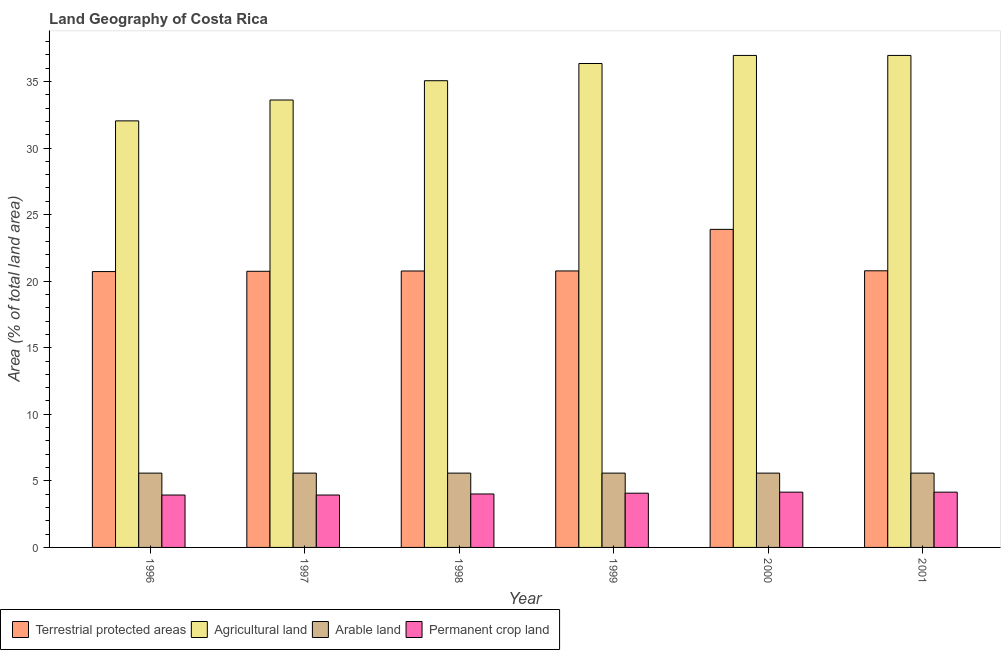How many different coloured bars are there?
Keep it short and to the point. 4. Are the number of bars on each tick of the X-axis equal?
Keep it short and to the point. Yes. What is the percentage of land under terrestrial protection in 2000?
Provide a succinct answer. 23.89. Across all years, what is the maximum percentage of area under agricultural land?
Offer a terse response. 36.96. Across all years, what is the minimum percentage of area under agricultural land?
Your answer should be very brief. 32.04. What is the total percentage of area under arable land in the graph?
Offer a terse response. 33.49. What is the difference between the percentage of area under arable land in 1996 and that in 1999?
Your answer should be compact. 0. What is the difference between the percentage of area under permanent crop land in 1997 and the percentage of area under arable land in 1998?
Provide a short and direct response. -0.08. What is the average percentage of area under permanent crop land per year?
Your answer should be compact. 4.04. In the year 2001, what is the difference between the percentage of area under permanent crop land and percentage of area under agricultural land?
Make the answer very short. 0. In how many years, is the percentage of land under terrestrial protection greater than 25 %?
Your answer should be compact. 0. What is the ratio of the percentage of area under arable land in 1997 to that in 2000?
Your response must be concise. 1. Is the percentage of area under permanent crop land in 1996 less than that in 2001?
Provide a succinct answer. Yes. Is the difference between the percentage of area under agricultural land in 1997 and 2001 greater than the difference between the percentage of area under arable land in 1997 and 2001?
Provide a succinct answer. No. What is the difference between the highest and the second highest percentage of area under arable land?
Your response must be concise. 0. What is the difference between the highest and the lowest percentage of land under terrestrial protection?
Ensure brevity in your answer.  3.17. In how many years, is the percentage of land under terrestrial protection greater than the average percentage of land under terrestrial protection taken over all years?
Give a very brief answer. 1. What does the 2nd bar from the left in 1998 represents?
Make the answer very short. Agricultural land. What does the 4th bar from the right in 1996 represents?
Your answer should be compact. Terrestrial protected areas. Is it the case that in every year, the sum of the percentage of land under terrestrial protection and percentage of area under agricultural land is greater than the percentage of area under arable land?
Provide a succinct answer. Yes. Where does the legend appear in the graph?
Your response must be concise. Bottom left. How many legend labels are there?
Your answer should be compact. 4. What is the title of the graph?
Provide a succinct answer. Land Geography of Costa Rica. What is the label or title of the X-axis?
Give a very brief answer. Year. What is the label or title of the Y-axis?
Provide a short and direct response. Area (% of total land area). What is the Area (% of total land area) of Terrestrial protected areas in 1996?
Provide a short and direct response. 20.72. What is the Area (% of total land area) of Agricultural land in 1996?
Offer a very short reply. 32.04. What is the Area (% of total land area) of Arable land in 1996?
Ensure brevity in your answer.  5.58. What is the Area (% of total land area) of Permanent crop land in 1996?
Make the answer very short. 3.94. What is the Area (% of total land area) in Terrestrial protected areas in 1997?
Your response must be concise. 20.74. What is the Area (% of total land area) in Agricultural land in 1997?
Keep it short and to the point. 33.61. What is the Area (% of total land area) of Arable land in 1997?
Provide a succinct answer. 5.58. What is the Area (% of total land area) in Permanent crop land in 1997?
Your answer should be compact. 3.94. What is the Area (% of total land area) of Terrestrial protected areas in 1998?
Offer a terse response. 20.76. What is the Area (% of total land area) of Agricultural land in 1998?
Your answer should be compact. 35.06. What is the Area (% of total land area) of Arable land in 1998?
Keep it short and to the point. 5.58. What is the Area (% of total land area) in Permanent crop land in 1998?
Your answer should be very brief. 4.01. What is the Area (% of total land area) in Terrestrial protected areas in 1999?
Keep it short and to the point. 20.77. What is the Area (% of total land area) in Agricultural land in 1999?
Offer a very short reply. 36.35. What is the Area (% of total land area) in Arable land in 1999?
Ensure brevity in your answer.  5.58. What is the Area (% of total land area) of Permanent crop land in 1999?
Ensure brevity in your answer.  4.07. What is the Area (% of total land area) of Terrestrial protected areas in 2000?
Keep it short and to the point. 23.89. What is the Area (% of total land area) in Agricultural land in 2000?
Offer a terse response. 36.96. What is the Area (% of total land area) in Arable land in 2000?
Your response must be concise. 5.58. What is the Area (% of total land area) in Permanent crop land in 2000?
Your answer should be compact. 4.15. What is the Area (% of total land area) of Terrestrial protected areas in 2001?
Offer a very short reply. 20.78. What is the Area (% of total land area) in Agricultural land in 2001?
Make the answer very short. 36.96. What is the Area (% of total land area) of Arable land in 2001?
Offer a very short reply. 5.58. What is the Area (% of total land area) in Permanent crop land in 2001?
Offer a terse response. 4.15. Across all years, what is the maximum Area (% of total land area) of Terrestrial protected areas?
Ensure brevity in your answer.  23.89. Across all years, what is the maximum Area (% of total land area) of Agricultural land?
Offer a very short reply. 36.96. Across all years, what is the maximum Area (% of total land area) of Arable land?
Your response must be concise. 5.58. Across all years, what is the maximum Area (% of total land area) of Permanent crop land?
Make the answer very short. 4.15. Across all years, what is the minimum Area (% of total land area) in Terrestrial protected areas?
Your answer should be very brief. 20.72. Across all years, what is the minimum Area (% of total land area) of Agricultural land?
Keep it short and to the point. 32.04. Across all years, what is the minimum Area (% of total land area) in Arable land?
Your answer should be very brief. 5.58. Across all years, what is the minimum Area (% of total land area) of Permanent crop land?
Your response must be concise. 3.94. What is the total Area (% of total land area) of Terrestrial protected areas in the graph?
Offer a very short reply. 127.67. What is the total Area (% of total land area) of Agricultural land in the graph?
Give a very brief answer. 210.97. What is the total Area (% of total land area) of Arable land in the graph?
Your answer should be very brief. 33.49. What is the total Area (% of total land area) in Permanent crop land in the graph?
Offer a very short reply. 24.27. What is the difference between the Area (% of total land area) of Terrestrial protected areas in 1996 and that in 1997?
Offer a terse response. -0.02. What is the difference between the Area (% of total land area) in Agricultural land in 1996 and that in 1997?
Your response must be concise. -1.57. What is the difference between the Area (% of total land area) of Arable land in 1996 and that in 1997?
Ensure brevity in your answer.  0. What is the difference between the Area (% of total land area) of Permanent crop land in 1996 and that in 1997?
Your answer should be compact. 0. What is the difference between the Area (% of total land area) in Terrestrial protected areas in 1996 and that in 1998?
Keep it short and to the point. -0.04. What is the difference between the Area (% of total land area) of Agricultural land in 1996 and that in 1998?
Your answer should be very brief. -3.02. What is the difference between the Area (% of total land area) in Permanent crop land in 1996 and that in 1998?
Keep it short and to the point. -0.08. What is the difference between the Area (% of total land area) of Terrestrial protected areas in 1996 and that in 1999?
Offer a terse response. -0.05. What is the difference between the Area (% of total land area) of Agricultural land in 1996 and that in 1999?
Your response must be concise. -4.31. What is the difference between the Area (% of total land area) of Permanent crop land in 1996 and that in 1999?
Your answer should be very brief. -0.14. What is the difference between the Area (% of total land area) of Terrestrial protected areas in 1996 and that in 2000?
Keep it short and to the point. -3.17. What is the difference between the Area (% of total land area) of Agricultural land in 1996 and that in 2000?
Make the answer very short. -4.92. What is the difference between the Area (% of total land area) of Arable land in 1996 and that in 2000?
Provide a succinct answer. 0. What is the difference between the Area (% of total land area) in Permanent crop land in 1996 and that in 2000?
Offer a terse response. -0.22. What is the difference between the Area (% of total land area) in Terrestrial protected areas in 1996 and that in 2001?
Your response must be concise. -0.06. What is the difference between the Area (% of total land area) in Agricultural land in 1996 and that in 2001?
Give a very brief answer. -4.92. What is the difference between the Area (% of total land area) of Arable land in 1996 and that in 2001?
Offer a terse response. 0. What is the difference between the Area (% of total land area) in Permanent crop land in 1996 and that in 2001?
Make the answer very short. -0.22. What is the difference between the Area (% of total land area) in Terrestrial protected areas in 1997 and that in 1998?
Give a very brief answer. -0.02. What is the difference between the Area (% of total land area) of Agricultural land in 1997 and that in 1998?
Offer a very short reply. -1.45. What is the difference between the Area (% of total land area) of Permanent crop land in 1997 and that in 1998?
Offer a very short reply. -0.08. What is the difference between the Area (% of total land area) of Terrestrial protected areas in 1997 and that in 1999?
Offer a very short reply. -0.03. What is the difference between the Area (% of total land area) in Agricultural land in 1997 and that in 1999?
Provide a short and direct response. -2.74. What is the difference between the Area (% of total land area) of Permanent crop land in 1997 and that in 1999?
Provide a succinct answer. -0.14. What is the difference between the Area (% of total land area) in Terrestrial protected areas in 1997 and that in 2000?
Offer a very short reply. -3.15. What is the difference between the Area (% of total land area) of Agricultural land in 1997 and that in 2000?
Your response must be concise. -3.35. What is the difference between the Area (% of total land area) in Permanent crop land in 1997 and that in 2000?
Keep it short and to the point. -0.22. What is the difference between the Area (% of total land area) in Terrestrial protected areas in 1997 and that in 2001?
Keep it short and to the point. -0.04. What is the difference between the Area (% of total land area) of Agricultural land in 1997 and that in 2001?
Offer a terse response. -3.35. What is the difference between the Area (% of total land area) in Permanent crop land in 1997 and that in 2001?
Keep it short and to the point. -0.22. What is the difference between the Area (% of total land area) of Terrestrial protected areas in 1998 and that in 1999?
Offer a terse response. -0. What is the difference between the Area (% of total land area) of Agricultural land in 1998 and that in 1999?
Ensure brevity in your answer.  -1.29. What is the difference between the Area (% of total land area) in Arable land in 1998 and that in 1999?
Keep it short and to the point. 0. What is the difference between the Area (% of total land area) in Permanent crop land in 1998 and that in 1999?
Provide a short and direct response. -0.06. What is the difference between the Area (% of total land area) in Terrestrial protected areas in 1998 and that in 2000?
Your answer should be compact. -3.13. What is the difference between the Area (% of total land area) in Agricultural land in 1998 and that in 2000?
Provide a short and direct response. -1.9. What is the difference between the Area (% of total land area) of Permanent crop land in 1998 and that in 2000?
Ensure brevity in your answer.  -0.14. What is the difference between the Area (% of total land area) in Terrestrial protected areas in 1998 and that in 2001?
Give a very brief answer. -0.02. What is the difference between the Area (% of total land area) in Agricultural land in 1998 and that in 2001?
Provide a succinct answer. -1.9. What is the difference between the Area (% of total land area) in Arable land in 1998 and that in 2001?
Your answer should be compact. 0. What is the difference between the Area (% of total land area) in Permanent crop land in 1998 and that in 2001?
Your response must be concise. -0.14. What is the difference between the Area (% of total land area) of Terrestrial protected areas in 1999 and that in 2000?
Your response must be concise. -3.12. What is the difference between the Area (% of total land area) in Agricultural land in 1999 and that in 2000?
Keep it short and to the point. -0.61. What is the difference between the Area (% of total land area) of Permanent crop land in 1999 and that in 2000?
Offer a very short reply. -0.08. What is the difference between the Area (% of total land area) in Terrestrial protected areas in 1999 and that in 2001?
Offer a terse response. -0.01. What is the difference between the Area (% of total land area) of Agricultural land in 1999 and that in 2001?
Provide a short and direct response. -0.61. What is the difference between the Area (% of total land area) in Arable land in 1999 and that in 2001?
Keep it short and to the point. 0. What is the difference between the Area (% of total land area) in Permanent crop land in 1999 and that in 2001?
Ensure brevity in your answer.  -0.08. What is the difference between the Area (% of total land area) in Terrestrial protected areas in 2000 and that in 2001?
Keep it short and to the point. 3.11. What is the difference between the Area (% of total land area) in Agricultural land in 2000 and that in 2001?
Give a very brief answer. 0. What is the difference between the Area (% of total land area) of Arable land in 2000 and that in 2001?
Provide a short and direct response. 0. What is the difference between the Area (% of total land area) of Permanent crop land in 2000 and that in 2001?
Make the answer very short. 0. What is the difference between the Area (% of total land area) in Terrestrial protected areas in 1996 and the Area (% of total land area) in Agricultural land in 1997?
Your answer should be very brief. -12.89. What is the difference between the Area (% of total land area) in Terrestrial protected areas in 1996 and the Area (% of total land area) in Arable land in 1997?
Your response must be concise. 15.14. What is the difference between the Area (% of total land area) of Terrestrial protected areas in 1996 and the Area (% of total land area) of Permanent crop land in 1997?
Keep it short and to the point. 16.78. What is the difference between the Area (% of total land area) in Agricultural land in 1996 and the Area (% of total land area) in Arable land in 1997?
Keep it short and to the point. 26.46. What is the difference between the Area (% of total land area) of Agricultural land in 1996 and the Area (% of total land area) of Permanent crop land in 1997?
Your answer should be very brief. 28.1. What is the difference between the Area (% of total land area) of Arable land in 1996 and the Area (% of total land area) of Permanent crop land in 1997?
Make the answer very short. 1.65. What is the difference between the Area (% of total land area) of Terrestrial protected areas in 1996 and the Area (% of total land area) of Agricultural land in 1998?
Provide a succinct answer. -14.34. What is the difference between the Area (% of total land area) of Terrestrial protected areas in 1996 and the Area (% of total land area) of Arable land in 1998?
Your answer should be very brief. 15.14. What is the difference between the Area (% of total land area) of Terrestrial protected areas in 1996 and the Area (% of total land area) of Permanent crop land in 1998?
Ensure brevity in your answer.  16.71. What is the difference between the Area (% of total land area) of Agricultural land in 1996 and the Area (% of total land area) of Arable land in 1998?
Your answer should be compact. 26.46. What is the difference between the Area (% of total land area) in Agricultural land in 1996 and the Area (% of total land area) in Permanent crop land in 1998?
Make the answer very short. 28.03. What is the difference between the Area (% of total land area) of Arable land in 1996 and the Area (% of total land area) of Permanent crop land in 1998?
Provide a succinct answer. 1.57. What is the difference between the Area (% of total land area) of Terrestrial protected areas in 1996 and the Area (% of total land area) of Agricultural land in 1999?
Provide a short and direct response. -15.63. What is the difference between the Area (% of total land area) in Terrestrial protected areas in 1996 and the Area (% of total land area) in Arable land in 1999?
Provide a succinct answer. 15.14. What is the difference between the Area (% of total land area) in Terrestrial protected areas in 1996 and the Area (% of total land area) in Permanent crop land in 1999?
Ensure brevity in your answer.  16.65. What is the difference between the Area (% of total land area) of Agricultural land in 1996 and the Area (% of total land area) of Arable land in 1999?
Provide a succinct answer. 26.46. What is the difference between the Area (% of total land area) of Agricultural land in 1996 and the Area (% of total land area) of Permanent crop land in 1999?
Provide a short and direct response. 27.97. What is the difference between the Area (% of total land area) of Arable land in 1996 and the Area (% of total land area) of Permanent crop land in 1999?
Provide a short and direct response. 1.51. What is the difference between the Area (% of total land area) in Terrestrial protected areas in 1996 and the Area (% of total land area) in Agricultural land in 2000?
Provide a succinct answer. -16.24. What is the difference between the Area (% of total land area) in Terrestrial protected areas in 1996 and the Area (% of total land area) in Arable land in 2000?
Offer a terse response. 15.14. What is the difference between the Area (% of total land area) in Terrestrial protected areas in 1996 and the Area (% of total land area) in Permanent crop land in 2000?
Offer a terse response. 16.57. What is the difference between the Area (% of total land area) of Agricultural land in 1996 and the Area (% of total land area) of Arable land in 2000?
Offer a terse response. 26.46. What is the difference between the Area (% of total land area) of Agricultural land in 1996 and the Area (% of total land area) of Permanent crop land in 2000?
Provide a short and direct response. 27.89. What is the difference between the Area (% of total land area) in Arable land in 1996 and the Area (% of total land area) in Permanent crop land in 2000?
Your answer should be compact. 1.43. What is the difference between the Area (% of total land area) of Terrestrial protected areas in 1996 and the Area (% of total land area) of Agricultural land in 2001?
Ensure brevity in your answer.  -16.24. What is the difference between the Area (% of total land area) of Terrestrial protected areas in 1996 and the Area (% of total land area) of Arable land in 2001?
Your response must be concise. 15.14. What is the difference between the Area (% of total land area) in Terrestrial protected areas in 1996 and the Area (% of total land area) in Permanent crop land in 2001?
Your response must be concise. 16.57. What is the difference between the Area (% of total land area) in Agricultural land in 1996 and the Area (% of total land area) in Arable land in 2001?
Give a very brief answer. 26.46. What is the difference between the Area (% of total land area) in Agricultural land in 1996 and the Area (% of total land area) in Permanent crop land in 2001?
Give a very brief answer. 27.89. What is the difference between the Area (% of total land area) in Arable land in 1996 and the Area (% of total land area) in Permanent crop land in 2001?
Keep it short and to the point. 1.43. What is the difference between the Area (% of total land area) of Terrestrial protected areas in 1997 and the Area (% of total land area) of Agricultural land in 1998?
Provide a short and direct response. -14.32. What is the difference between the Area (% of total land area) in Terrestrial protected areas in 1997 and the Area (% of total land area) in Arable land in 1998?
Give a very brief answer. 15.16. What is the difference between the Area (% of total land area) of Terrestrial protected areas in 1997 and the Area (% of total land area) of Permanent crop land in 1998?
Offer a very short reply. 16.73. What is the difference between the Area (% of total land area) of Agricultural land in 1997 and the Area (% of total land area) of Arable land in 1998?
Ensure brevity in your answer.  28.03. What is the difference between the Area (% of total land area) in Agricultural land in 1997 and the Area (% of total land area) in Permanent crop land in 1998?
Your answer should be compact. 29.59. What is the difference between the Area (% of total land area) in Arable land in 1997 and the Area (% of total land area) in Permanent crop land in 1998?
Keep it short and to the point. 1.57. What is the difference between the Area (% of total land area) in Terrestrial protected areas in 1997 and the Area (% of total land area) in Agricultural land in 1999?
Keep it short and to the point. -15.61. What is the difference between the Area (% of total land area) in Terrestrial protected areas in 1997 and the Area (% of total land area) in Arable land in 1999?
Ensure brevity in your answer.  15.16. What is the difference between the Area (% of total land area) in Terrestrial protected areas in 1997 and the Area (% of total land area) in Permanent crop land in 1999?
Ensure brevity in your answer.  16.67. What is the difference between the Area (% of total land area) of Agricultural land in 1997 and the Area (% of total land area) of Arable land in 1999?
Make the answer very short. 28.03. What is the difference between the Area (% of total land area) in Agricultural land in 1997 and the Area (% of total land area) in Permanent crop land in 1999?
Your answer should be very brief. 29.53. What is the difference between the Area (% of total land area) of Arable land in 1997 and the Area (% of total land area) of Permanent crop land in 1999?
Provide a short and direct response. 1.51. What is the difference between the Area (% of total land area) of Terrestrial protected areas in 1997 and the Area (% of total land area) of Agricultural land in 2000?
Offer a terse response. -16.21. What is the difference between the Area (% of total land area) of Terrestrial protected areas in 1997 and the Area (% of total land area) of Arable land in 2000?
Your answer should be compact. 15.16. What is the difference between the Area (% of total land area) in Terrestrial protected areas in 1997 and the Area (% of total land area) in Permanent crop land in 2000?
Ensure brevity in your answer.  16.59. What is the difference between the Area (% of total land area) of Agricultural land in 1997 and the Area (% of total land area) of Arable land in 2000?
Your answer should be compact. 28.03. What is the difference between the Area (% of total land area) of Agricultural land in 1997 and the Area (% of total land area) of Permanent crop land in 2000?
Offer a very short reply. 29.46. What is the difference between the Area (% of total land area) in Arable land in 1997 and the Area (% of total land area) in Permanent crop land in 2000?
Offer a terse response. 1.43. What is the difference between the Area (% of total land area) in Terrestrial protected areas in 1997 and the Area (% of total land area) in Agricultural land in 2001?
Your response must be concise. -16.21. What is the difference between the Area (% of total land area) of Terrestrial protected areas in 1997 and the Area (% of total land area) of Arable land in 2001?
Provide a short and direct response. 15.16. What is the difference between the Area (% of total land area) in Terrestrial protected areas in 1997 and the Area (% of total land area) in Permanent crop land in 2001?
Provide a short and direct response. 16.59. What is the difference between the Area (% of total land area) in Agricultural land in 1997 and the Area (% of total land area) in Arable land in 2001?
Your response must be concise. 28.03. What is the difference between the Area (% of total land area) in Agricultural land in 1997 and the Area (% of total land area) in Permanent crop land in 2001?
Make the answer very short. 29.46. What is the difference between the Area (% of total land area) of Arable land in 1997 and the Area (% of total land area) of Permanent crop land in 2001?
Your answer should be very brief. 1.43. What is the difference between the Area (% of total land area) of Terrestrial protected areas in 1998 and the Area (% of total land area) of Agricultural land in 1999?
Your answer should be compact. -15.59. What is the difference between the Area (% of total land area) in Terrestrial protected areas in 1998 and the Area (% of total land area) in Arable land in 1999?
Your response must be concise. 15.18. What is the difference between the Area (% of total land area) in Terrestrial protected areas in 1998 and the Area (% of total land area) in Permanent crop land in 1999?
Ensure brevity in your answer.  16.69. What is the difference between the Area (% of total land area) of Agricultural land in 1998 and the Area (% of total land area) of Arable land in 1999?
Your answer should be very brief. 29.48. What is the difference between the Area (% of total land area) of Agricultural land in 1998 and the Area (% of total land area) of Permanent crop land in 1999?
Your response must be concise. 30.98. What is the difference between the Area (% of total land area) in Arable land in 1998 and the Area (% of total land area) in Permanent crop land in 1999?
Make the answer very short. 1.51. What is the difference between the Area (% of total land area) of Terrestrial protected areas in 1998 and the Area (% of total land area) of Agricultural land in 2000?
Give a very brief answer. -16.19. What is the difference between the Area (% of total land area) of Terrestrial protected areas in 1998 and the Area (% of total land area) of Arable land in 2000?
Your answer should be very brief. 15.18. What is the difference between the Area (% of total land area) of Terrestrial protected areas in 1998 and the Area (% of total land area) of Permanent crop land in 2000?
Offer a terse response. 16.61. What is the difference between the Area (% of total land area) in Agricultural land in 1998 and the Area (% of total land area) in Arable land in 2000?
Your answer should be very brief. 29.48. What is the difference between the Area (% of total land area) of Agricultural land in 1998 and the Area (% of total land area) of Permanent crop land in 2000?
Offer a very short reply. 30.9. What is the difference between the Area (% of total land area) of Arable land in 1998 and the Area (% of total land area) of Permanent crop land in 2000?
Your answer should be very brief. 1.43. What is the difference between the Area (% of total land area) in Terrestrial protected areas in 1998 and the Area (% of total land area) in Agricultural land in 2001?
Your answer should be very brief. -16.19. What is the difference between the Area (% of total land area) in Terrestrial protected areas in 1998 and the Area (% of total land area) in Arable land in 2001?
Give a very brief answer. 15.18. What is the difference between the Area (% of total land area) in Terrestrial protected areas in 1998 and the Area (% of total land area) in Permanent crop land in 2001?
Make the answer very short. 16.61. What is the difference between the Area (% of total land area) of Agricultural land in 1998 and the Area (% of total land area) of Arable land in 2001?
Your response must be concise. 29.48. What is the difference between the Area (% of total land area) in Agricultural land in 1998 and the Area (% of total land area) in Permanent crop land in 2001?
Your answer should be very brief. 30.9. What is the difference between the Area (% of total land area) in Arable land in 1998 and the Area (% of total land area) in Permanent crop land in 2001?
Keep it short and to the point. 1.43. What is the difference between the Area (% of total land area) of Terrestrial protected areas in 1999 and the Area (% of total land area) of Agricultural land in 2000?
Ensure brevity in your answer.  -16.19. What is the difference between the Area (% of total land area) of Terrestrial protected areas in 1999 and the Area (% of total land area) of Arable land in 2000?
Give a very brief answer. 15.19. What is the difference between the Area (% of total land area) of Terrestrial protected areas in 1999 and the Area (% of total land area) of Permanent crop land in 2000?
Make the answer very short. 16.62. What is the difference between the Area (% of total land area) in Agricultural land in 1999 and the Area (% of total land area) in Arable land in 2000?
Provide a succinct answer. 30.77. What is the difference between the Area (% of total land area) in Agricultural land in 1999 and the Area (% of total land area) in Permanent crop land in 2000?
Offer a terse response. 32.2. What is the difference between the Area (% of total land area) in Arable land in 1999 and the Area (% of total land area) in Permanent crop land in 2000?
Ensure brevity in your answer.  1.43. What is the difference between the Area (% of total land area) of Terrestrial protected areas in 1999 and the Area (% of total land area) of Agricultural land in 2001?
Keep it short and to the point. -16.19. What is the difference between the Area (% of total land area) in Terrestrial protected areas in 1999 and the Area (% of total land area) in Arable land in 2001?
Make the answer very short. 15.19. What is the difference between the Area (% of total land area) of Terrestrial protected areas in 1999 and the Area (% of total land area) of Permanent crop land in 2001?
Ensure brevity in your answer.  16.62. What is the difference between the Area (% of total land area) in Agricultural land in 1999 and the Area (% of total land area) in Arable land in 2001?
Offer a very short reply. 30.77. What is the difference between the Area (% of total land area) of Agricultural land in 1999 and the Area (% of total land area) of Permanent crop land in 2001?
Your response must be concise. 32.2. What is the difference between the Area (% of total land area) of Arable land in 1999 and the Area (% of total land area) of Permanent crop land in 2001?
Your answer should be compact. 1.43. What is the difference between the Area (% of total land area) in Terrestrial protected areas in 2000 and the Area (% of total land area) in Agricultural land in 2001?
Ensure brevity in your answer.  -13.07. What is the difference between the Area (% of total land area) in Terrestrial protected areas in 2000 and the Area (% of total land area) in Arable land in 2001?
Provide a short and direct response. 18.31. What is the difference between the Area (% of total land area) of Terrestrial protected areas in 2000 and the Area (% of total land area) of Permanent crop land in 2001?
Your answer should be compact. 19.74. What is the difference between the Area (% of total land area) of Agricultural land in 2000 and the Area (% of total land area) of Arable land in 2001?
Keep it short and to the point. 31.37. What is the difference between the Area (% of total land area) in Agricultural land in 2000 and the Area (% of total land area) in Permanent crop land in 2001?
Give a very brief answer. 32.8. What is the difference between the Area (% of total land area) of Arable land in 2000 and the Area (% of total land area) of Permanent crop land in 2001?
Give a very brief answer. 1.43. What is the average Area (% of total land area) in Terrestrial protected areas per year?
Your answer should be compact. 21.28. What is the average Area (% of total land area) of Agricultural land per year?
Your response must be concise. 35.16. What is the average Area (% of total land area) of Arable land per year?
Provide a short and direct response. 5.58. What is the average Area (% of total land area) of Permanent crop land per year?
Ensure brevity in your answer.  4.04. In the year 1996, what is the difference between the Area (% of total land area) in Terrestrial protected areas and Area (% of total land area) in Agricultural land?
Keep it short and to the point. -11.32. In the year 1996, what is the difference between the Area (% of total land area) of Terrestrial protected areas and Area (% of total land area) of Arable land?
Make the answer very short. 15.14. In the year 1996, what is the difference between the Area (% of total land area) of Terrestrial protected areas and Area (% of total land area) of Permanent crop land?
Provide a succinct answer. 16.78. In the year 1996, what is the difference between the Area (% of total land area) in Agricultural land and Area (% of total land area) in Arable land?
Your answer should be very brief. 26.46. In the year 1996, what is the difference between the Area (% of total land area) of Agricultural land and Area (% of total land area) of Permanent crop land?
Your answer should be compact. 28.1. In the year 1996, what is the difference between the Area (% of total land area) in Arable land and Area (% of total land area) in Permanent crop land?
Make the answer very short. 1.65. In the year 1997, what is the difference between the Area (% of total land area) in Terrestrial protected areas and Area (% of total land area) in Agricultural land?
Offer a terse response. -12.87. In the year 1997, what is the difference between the Area (% of total land area) in Terrestrial protected areas and Area (% of total land area) in Arable land?
Your response must be concise. 15.16. In the year 1997, what is the difference between the Area (% of total land area) in Terrestrial protected areas and Area (% of total land area) in Permanent crop land?
Keep it short and to the point. 16.81. In the year 1997, what is the difference between the Area (% of total land area) of Agricultural land and Area (% of total land area) of Arable land?
Provide a succinct answer. 28.03. In the year 1997, what is the difference between the Area (% of total land area) in Agricultural land and Area (% of total land area) in Permanent crop land?
Ensure brevity in your answer.  29.67. In the year 1997, what is the difference between the Area (% of total land area) in Arable land and Area (% of total land area) in Permanent crop land?
Keep it short and to the point. 1.65. In the year 1998, what is the difference between the Area (% of total land area) of Terrestrial protected areas and Area (% of total land area) of Agricultural land?
Your response must be concise. -14.29. In the year 1998, what is the difference between the Area (% of total land area) in Terrestrial protected areas and Area (% of total land area) in Arable land?
Provide a succinct answer. 15.18. In the year 1998, what is the difference between the Area (% of total land area) in Terrestrial protected areas and Area (% of total land area) in Permanent crop land?
Your answer should be compact. 16.75. In the year 1998, what is the difference between the Area (% of total land area) in Agricultural land and Area (% of total land area) in Arable land?
Keep it short and to the point. 29.48. In the year 1998, what is the difference between the Area (% of total land area) of Agricultural land and Area (% of total land area) of Permanent crop land?
Your answer should be very brief. 31.04. In the year 1998, what is the difference between the Area (% of total land area) in Arable land and Area (% of total land area) in Permanent crop land?
Keep it short and to the point. 1.57. In the year 1999, what is the difference between the Area (% of total land area) of Terrestrial protected areas and Area (% of total land area) of Agricultural land?
Provide a short and direct response. -15.58. In the year 1999, what is the difference between the Area (% of total land area) in Terrestrial protected areas and Area (% of total land area) in Arable land?
Your answer should be very brief. 15.19. In the year 1999, what is the difference between the Area (% of total land area) in Terrestrial protected areas and Area (% of total land area) in Permanent crop land?
Give a very brief answer. 16.69. In the year 1999, what is the difference between the Area (% of total land area) in Agricultural land and Area (% of total land area) in Arable land?
Your answer should be very brief. 30.77. In the year 1999, what is the difference between the Area (% of total land area) of Agricultural land and Area (% of total land area) of Permanent crop land?
Your answer should be very brief. 32.28. In the year 1999, what is the difference between the Area (% of total land area) in Arable land and Area (% of total land area) in Permanent crop land?
Provide a succinct answer. 1.51. In the year 2000, what is the difference between the Area (% of total land area) in Terrestrial protected areas and Area (% of total land area) in Agricultural land?
Ensure brevity in your answer.  -13.07. In the year 2000, what is the difference between the Area (% of total land area) in Terrestrial protected areas and Area (% of total land area) in Arable land?
Give a very brief answer. 18.31. In the year 2000, what is the difference between the Area (% of total land area) in Terrestrial protected areas and Area (% of total land area) in Permanent crop land?
Offer a very short reply. 19.74. In the year 2000, what is the difference between the Area (% of total land area) in Agricultural land and Area (% of total land area) in Arable land?
Keep it short and to the point. 31.37. In the year 2000, what is the difference between the Area (% of total land area) of Agricultural land and Area (% of total land area) of Permanent crop land?
Give a very brief answer. 32.8. In the year 2000, what is the difference between the Area (% of total land area) in Arable land and Area (% of total land area) in Permanent crop land?
Keep it short and to the point. 1.43. In the year 2001, what is the difference between the Area (% of total land area) of Terrestrial protected areas and Area (% of total land area) of Agricultural land?
Make the answer very short. -16.18. In the year 2001, what is the difference between the Area (% of total land area) of Terrestrial protected areas and Area (% of total land area) of Arable land?
Provide a short and direct response. 15.2. In the year 2001, what is the difference between the Area (% of total land area) of Terrestrial protected areas and Area (% of total land area) of Permanent crop land?
Offer a very short reply. 16.63. In the year 2001, what is the difference between the Area (% of total land area) of Agricultural land and Area (% of total land area) of Arable land?
Provide a succinct answer. 31.37. In the year 2001, what is the difference between the Area (% of total land area) in Agricultural land and Area (% of total land area) in Permanent crop land?
Your answer should be compact. 32.8. In the year 2001, what is the difference between the Area (% of total land area) of Arable land and Area (% of total land area) of Permanent crop land?
Your response must be concise. 1.43. What is the ratio of the Area (% of total land area) in Terrestrial protected areas in 1996 to that in 1997?
Your answer should be compact. 1. What is the ratio of the Area (% of total land area) of Agricultural land in 1996 to that in 1997?
Offer a very short reply. 0.95. What is the ratio of the Area (% of total land area) in Arable land in 1996 to that in 1997?
Provide a succinct answer. 1. What is the ratio of the Area (% of total land area) of Permanent crop land in 1996 to that in 1997?
Give a very brief answer. 1. What is the ratio of the Area (% of total land area) in Terrestrial protected areas in 1996 to that in 1998?
Provide a succinct answer. 1. What is the ratio of the Area (% of total land area) of Agricultural land in 1996 to that in 1998?
Your response must be concise. 0.91. What is the ratio of the Area (% of total land area) in Arable land in 1996 to that in 1998?
Give a very brief answer. 1. What is the ratio of the Area (% of total land area) in Permanent crop land in 1996 to that in 1998?
Give a very brief answer. 0.98. What is the ratio of the Area (% of total land area) of Agricultural land in 1996 to that in 1999?
Your response must be concise. 0.88. What is the ratio of the Area (% of total land area) in Permanent crop land in 1996 to that in 1999?
Your answer should be very brief. 0.97. What is the ratio of the Area (% of total land area) of Terrestrial protected areas in 1996 to that in 2000?
Your answer should be very brief. 0.87. What is the ratio of the Area (% of total land area) in Agricultural land in 1996 to that in 2000?
Provide a short and direct response. 0.87. What is the ratio of the Area (% of total land area) of Permanent crop land in 1996 to that in 2000?
Provide a succinct answer. 0.95. What is the ratio of the Area (% of total land area) of Terrestrial protected areas in 1996 to that in 2001?
Make the answer very short. 1. What is the ratio of the Area (% of total land area) in Agricultural land in 1996 to that in 2001?
Make the answer very short. 0.87. What is the ratio of the Area (% of total land area) of Permanent crop land in 1996 to that in 2001?
Give a very brief answer. 0.95. What is the ratio of the Area (% of total land area) in Agricultural land in 1997 to that in 1998?
Ensure brevity in your answer.  0.96. What is the ratio of the Area (% of total land area) of Arable land in 1997 to that in 1998?
Your answer should be compact. 1. What is the ratio of the Area (% of total land area) in Permanent crop land in 1997 to that in 1998?
Your answer should be very brief. 0.98. What is the ratio of the Area (% of total land area) in Agricultural land in 1997 to that in 1999?
Ensure brevity in your answer.  0.92. What is the ratio of the Area (% of total land area) in Permanent crop land in 1997 to that in 1999?
Your answer should be compact. 0.97. What is the ratio of the Area (% of total land area) of Terrestrial protected areas in 1997 to that in 2000?
Offer a very short reply. 0.87. What is the ratio of the Area (% of total land area) in Agricultural land in 1997 to that in 2000?
Your answer should be compact. 0.91. What is the ratio of the Area (% of total land area) of Permanent crop land in 1997 to that in 2000?
Keep it short and to the point. 0.95. What is the ratio of the Area (% of total land area) in Terrestrial protected areas in 1997 to that in 2001?
Offer a terse response. 1. What is the ratio of the Area (% of total land area) in Agricultural land in 1997 to that in 2001?
Give a very brief answer. 0.91. What is the ratio of the Area (% of total land area) of Arable land in 1997 to that in 2001?
Keep it short and to the point. 1. What is the ratio of the Area (% of total land area) of Permanent crop land in 1997 to that in 2001?
Your answer should be very brief. 0.95. What is the ratio of the Area (% of total land area) of Agricultural land in 1998 to that in 1999?
Give a very brief answer. 0.96. What is the ratio of the Area (% of total land area) in Arable land in 1998 to that in 1999?
Give a very brief answer. 1. What is the ratio of the Area (% of total land area) in Permanent crop land in 1998 to that in 1999?
Your answer should be compact. 0.99. What is the ratio of the Area (% of total land area) in Terrestrial protected areas in 1998 to that in 2000?
Your response must be concise. 0.87. What is the ratio of the Area (% of total land area) in Agricultural land in 1998 to that in 2000?
Ensure brevity in your answer.  0.95. What is the ratio of the Area (% of total land area) of Agricultural land in 1998 to that in 2001?
Provide a short and direct response. 0.95. What is the ratio of the Area (% of total land area) in Arable land in 1998 to that in 2001?
Your answer should be compact. 1. What is the ratio of the Area (% of total land area) of Permanent crop land in 1998 to that in 2001?
Offer a terse response. 0.97. What is the ratio of the Area (% of total land area) in Terrestrial protected areas in 1999 to that in 2000?
Your answer should be compact. 0.87. What is the ratio of the Area (% of total land area) of Agricultural land in 1999 to that in 2000?
Your answer should be very brief. 0.98. What is the ratio of the Area (% of total land area) in Permanent crop land in 1999 to that in 2000?
Your answer should be very brief. 0.98. What is the ratio of the Area (% of total land area) of Agricultural land in 1999 to that in 2001?
Offer a terse response. 0.98. What is the ratio of the Area (% of total land area) in Arable land in 1999 to that in 2001?
Give a very brief answer. 1. What is the ratio of the Area (% of total land area) of Permanent crop land in 1999 to that in 2001?
Ensure brevity in your answer.  0.98. What is the ratio of the Area (% of total land area) of Terrestrial protected areas in 2000 to that in 2001?
Your answer should be very brief. 1.15. What is the difference between the highest and the second highest Area (% of total land area) of Terrestrial protected areas?
Your answer should be compact. 3.11. What is the difference between the highest and the second highest Area (% of total land area) of Permanent crop land?
Your answer should be very brief. 0. What is the difference between the highest and the lowest Area (% of total land area) of Terrestrial protected areas?
Ensure brevity in your answer.  3.17. What is the difference between the highest and the lowest Area (% of total land area) in Agricultural land?
Keep it short and to the point. 4.92. What is the difference between the highest and the lowest Area (% of total land area) in Arable land?
Give a very brief answer. 0. What is the difference between the highest and the lowest Area (% of total land area) in Permanent crop land?
Your answer should be very brief. 0.22. 